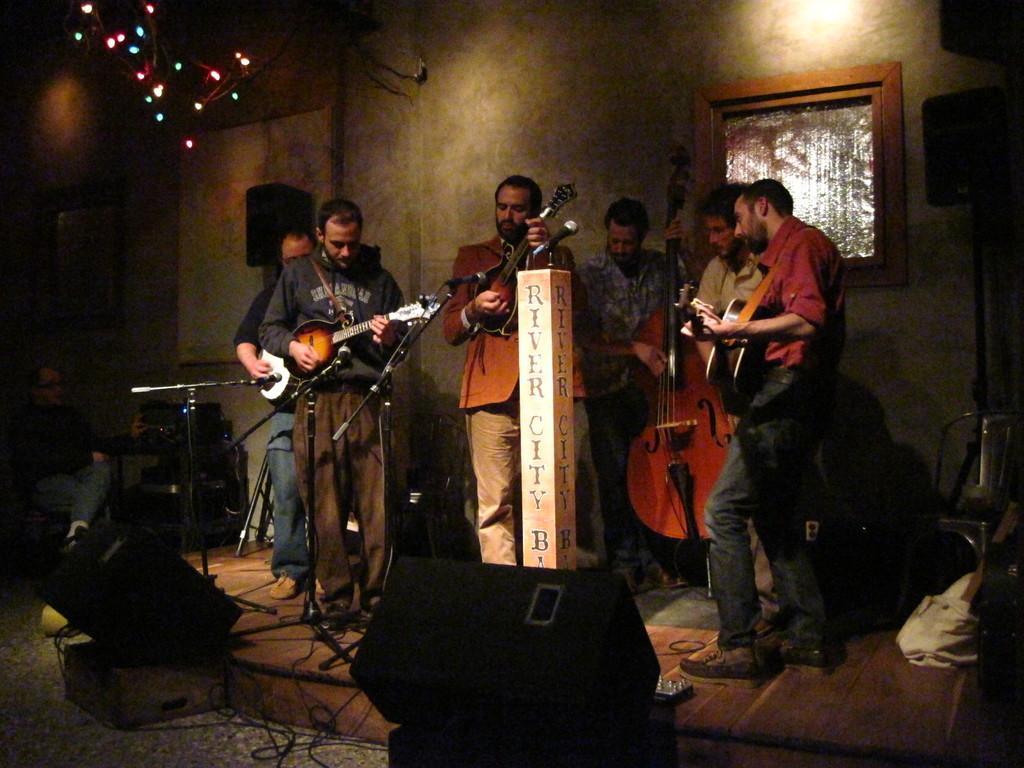Please provide a concise description of this image. There is a group of people. They are standing on a stage. They are playing a musical instruments. 